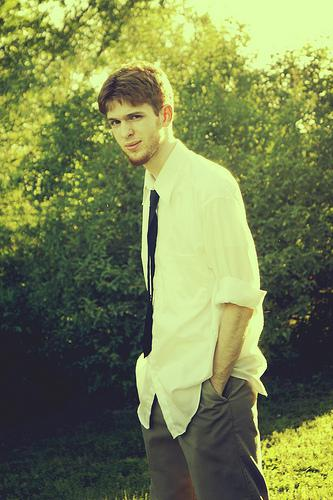Question: when was the picture taken?
Choices:
A. In the daytime.
B. Morning.
C. Evening.
D. Afternoon.
Answer with the letter. Answer: A Question: where was the picture taken?
Choices:
A. Outside, in the sand.
B. Outside in the grass.
C. Inside, on the carpet.
D. Outside, on the sidewalk.
Answer with the letter. Answer: B Question: what color are his pants?
Choices:
A. Black.
B. Brown.
C. Blue.
D. Gray.
Answer with the letter. Answer: D Question: how many people are in the picture?
Choices:
A. 5.
B. 3.
C. 7.
D. 1.
Answer with the letter. Answer: D 